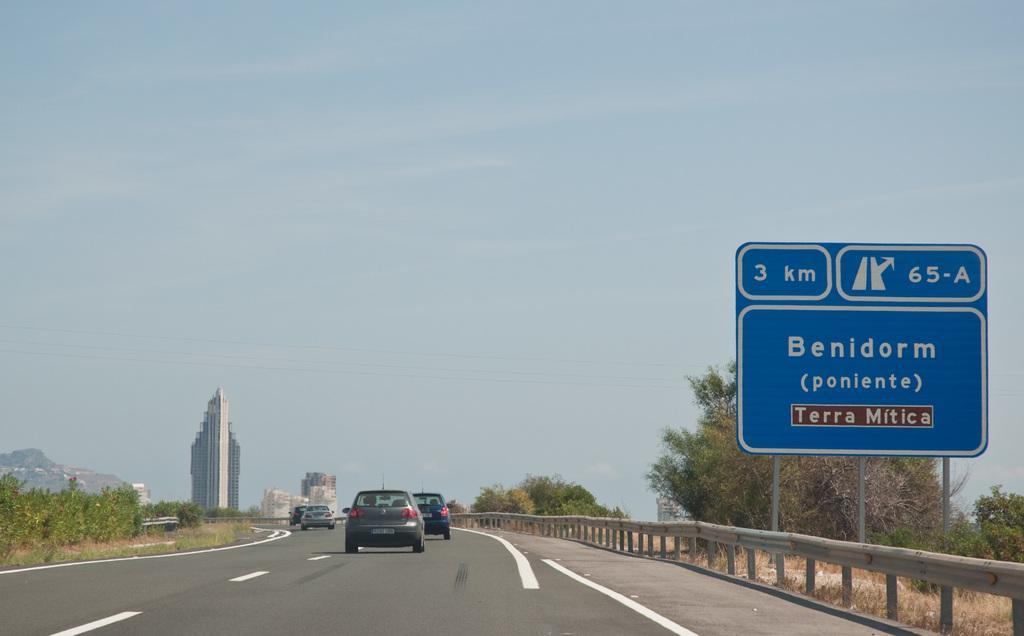Please provide a concise description of this image. There is a road with vehicles running on that. On the right side there are railings, trees and a sign board with poles. On the left side there are plants. In the back there are buildings and sky. 